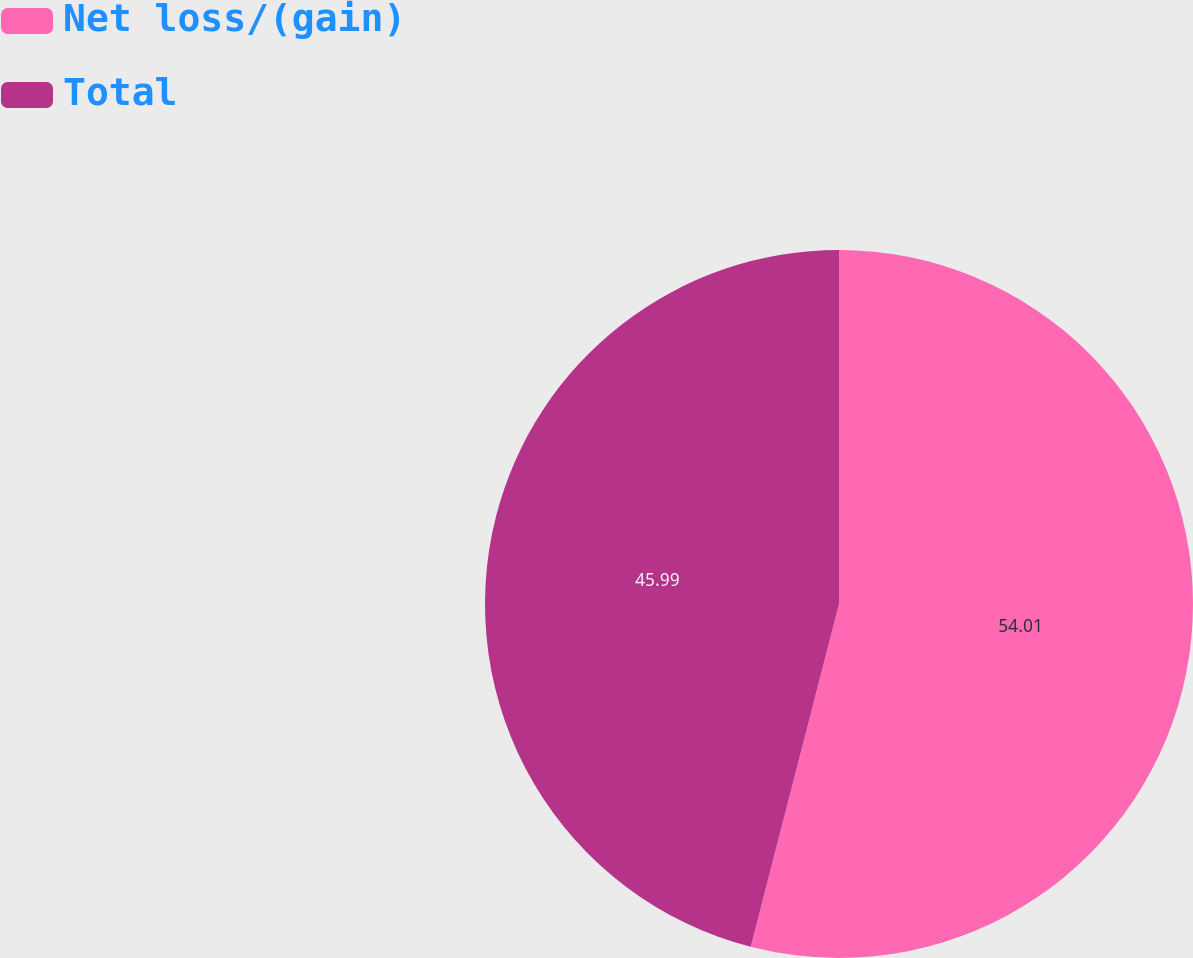Convert chart to OTSL. <chart><loc_0><loc_0><loc_500><loc_500><pie_chart><fcel>Net loss/(gain)<fcel>Total<nl><fcel>54.01%<fcel>45.99%<nl></chart> 